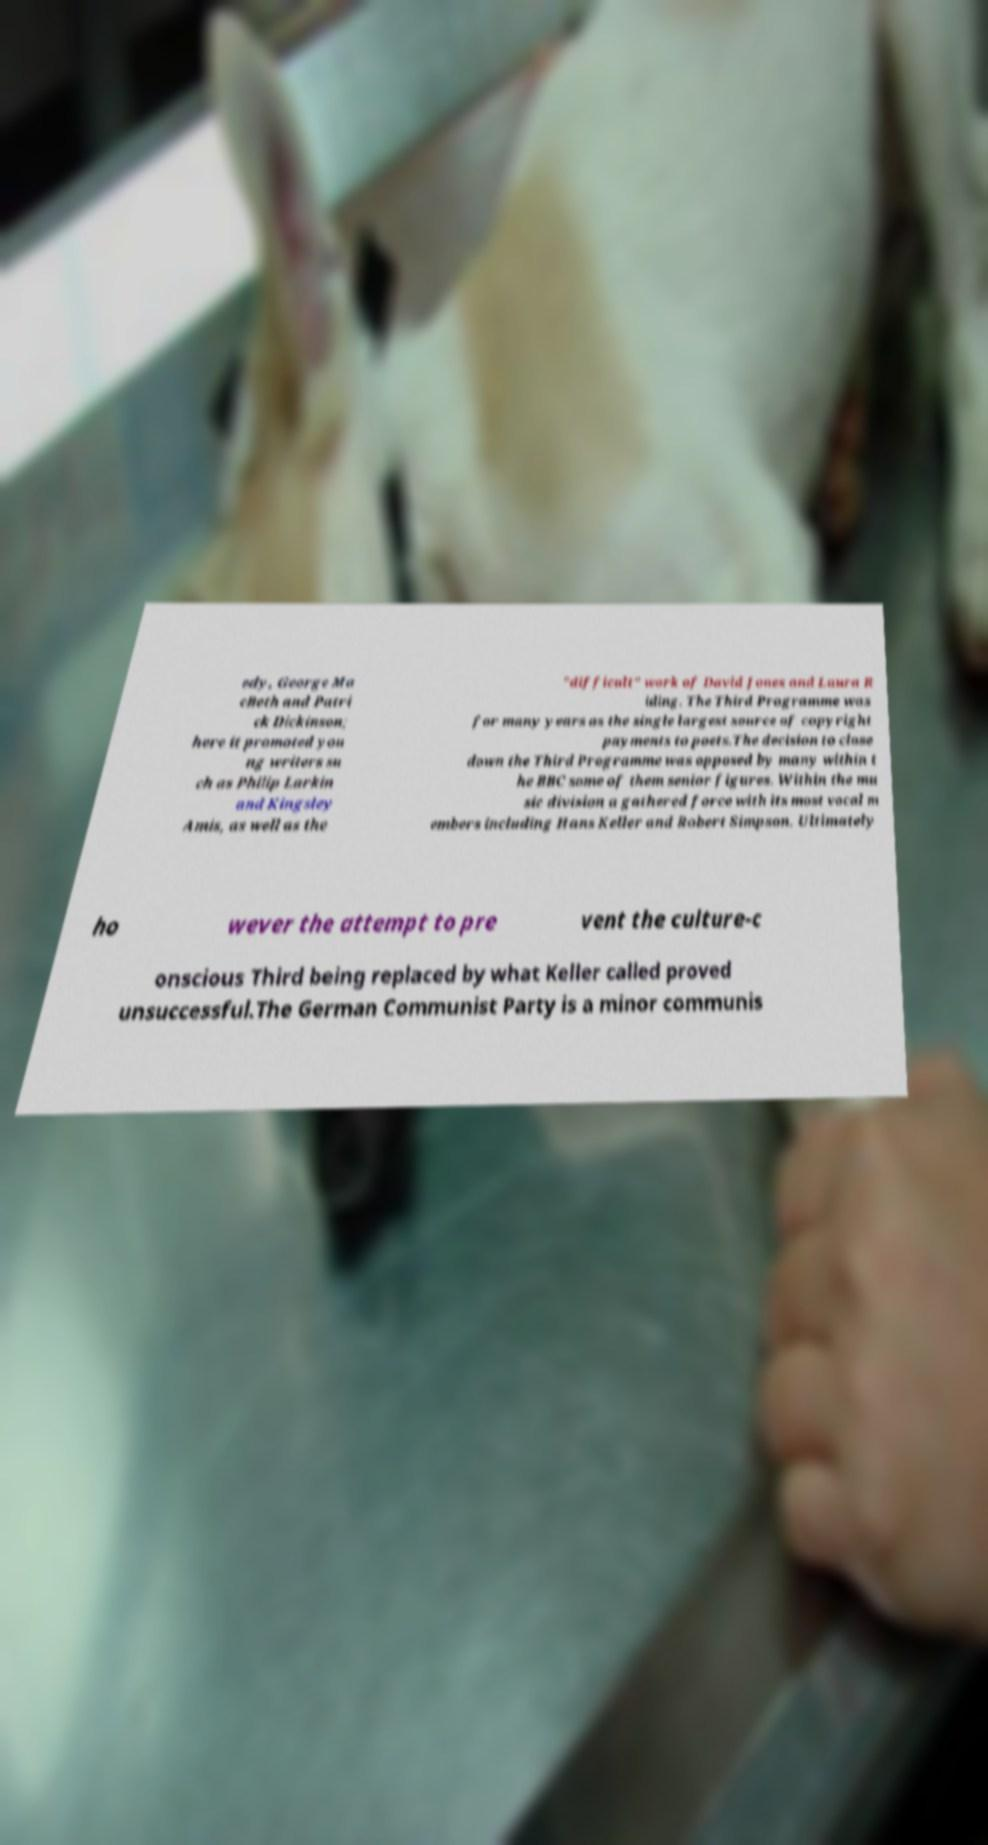Could you extract and type out the text from this image? edy, George Ma cBeth and Patri ck Dickinson; here it promoted you ng writers su ch as Philip Larkin and Kingsley Amis, as well as the "difficult" work of David Jones and Laura R iding. The Third Programme was for many years as the single largest source of copyright payments to poets.The decision to close down the Third Programme was opposed by many within t he BBC some of them senior figures. Within the mu sic division a gathered force with its most vocal m embers including Hans Keller and Robert Simpson. Ultimately ho wever the attempt to pre vent the culture-c onscious Third being replaced by what Keller called proved unsuccessful.The German Communist Party is a minor communis 